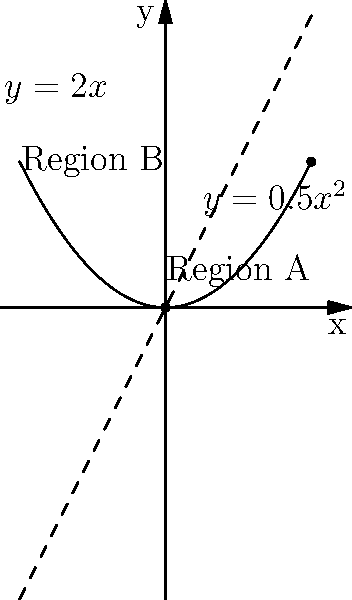A seed provider is analyzing the spread of a rare plant species across two geographical regions, A and B. The genetic diversity in Region A is represented by the function $y=0.5x^2$, while in Region B, it's represented by $y=2x$. The variable $x$ represents the distance from the origin (in km), and $y$ represents the genetic diversity index. Calculate the vector from the origin to the point where the genetic diversity is equal in both regions. What does this vector tell us about the spread of genetic diversity? To solve this problem, we need to follow these steps:

1) First, we need to find the point where the genetic diversity is equal in both regions. This occurs where the two functions intersect:

   $0.5x^2 = 2x$

2) Rearranging the equation:

   $0.5x^2 - 2x = 0$
   $x(0.5x - 2) = 0$

3) Solving this equation:
   
   $x = 0$ or $0.5x - 2 = 0$
   
   For the second part: $x = 4$

4) The point $x = 0$ is trivial (the origin), so we're interested in $x = 4$.

5) To find the y-coordinate, we can use either function. Let's use $y = 2x$:

   $y = 2(4) = 8$

6) So, the point of intersection is $(4, 8)$.

7) The vector from the origin to this point is:

   $\vec{v} = \langle 4, 8 \rangle$

8) This vector tells us that the genetic diversity spreads 4 km from the origin and reaches a diversity index of 8 at that point. The magnitude of this vector is:

   $|\vec{v}| = \sqrt{4^2 + 8^2} = \sqrt{80} \approx 8.94$ km

This indicates the direct distance from the origin to the point of equal genetic diversity.
Answer: $\vec{v} = \langle 4, 8 \rangle$ 